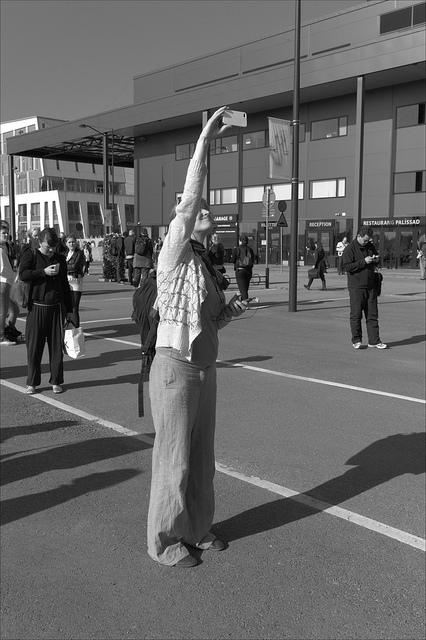Why is the woman holding her phone above her head? Please explain your reasoning. taking photo. The higher the phone the more background she can get in the picture. 